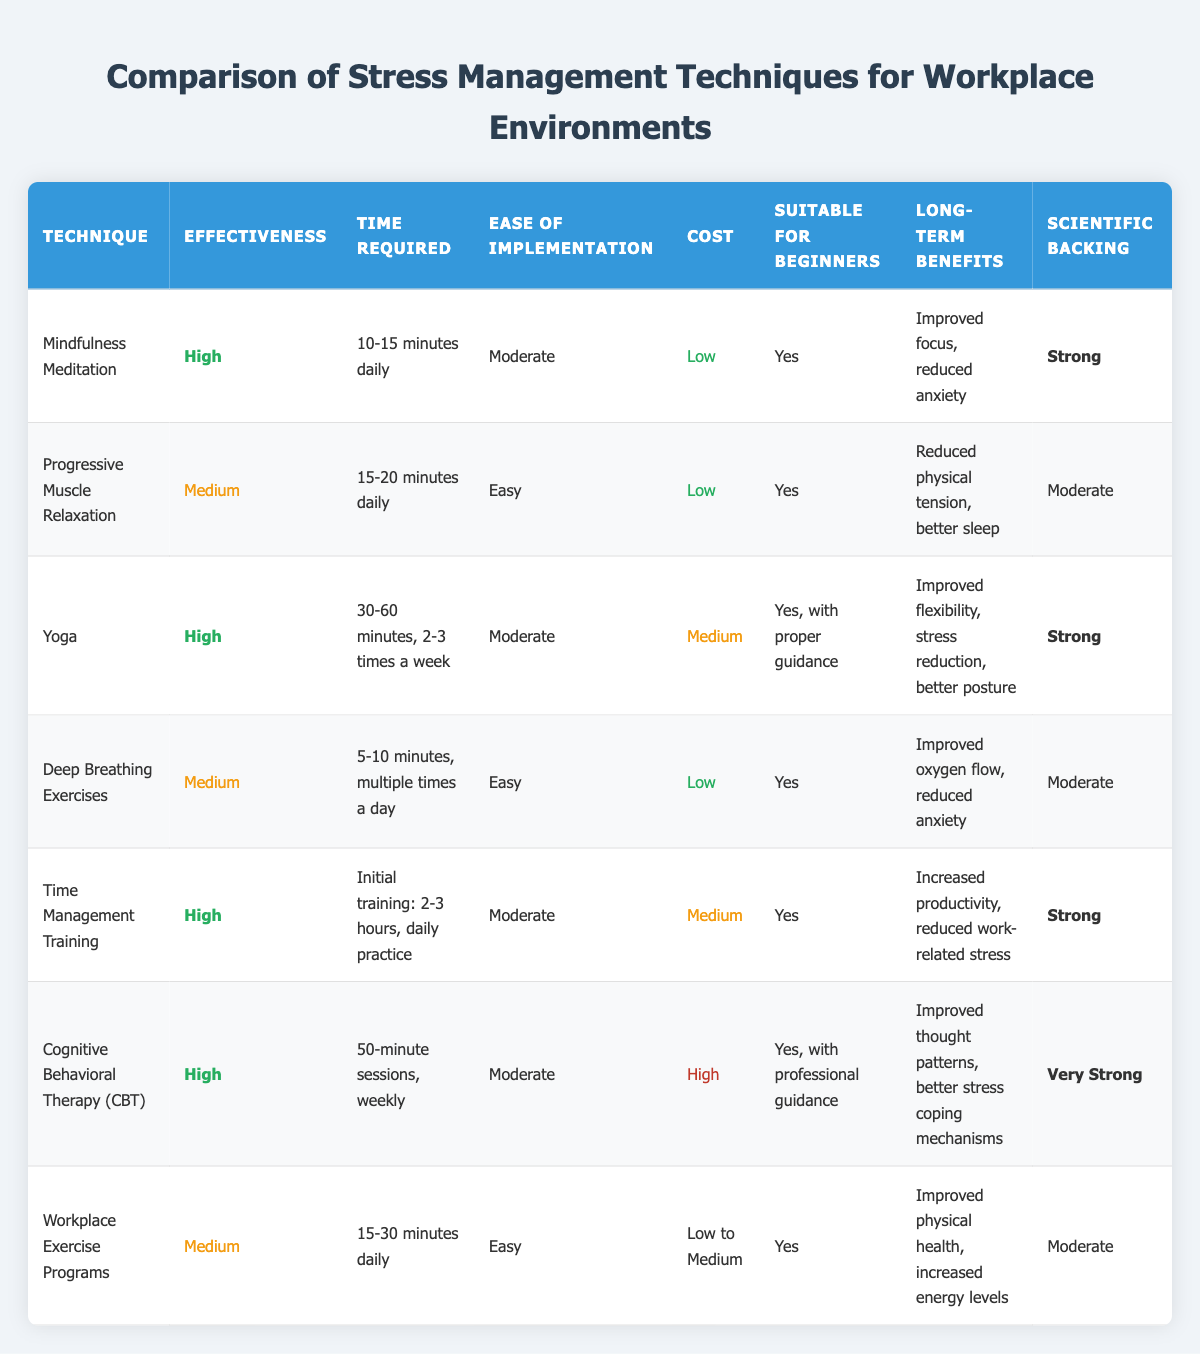What is the effectiveness of Cognitive Behavioral Therapy (CBT)? The effectiveness of Cognitive Behavioral Therapy (CBT) is listed in the table as "High."
Answer: High How much time is required for Mindfulness Meditation? According to the table, the time required for Mindfulness Meditation is "10-15 minutes daily."
Answer: 10-15 minutes daily Is Yoga suitable for beginners according to the table? The table states that Yoga is suitable for beginners "Yes, with proper guidance," indicating that beginners can practice it but may need assistance initially.
Answer: Yes What are the long-term benefits of Time Management Training? The table indicates that the long-term benefits of Time Management Training include "Increased productivity, reduced work-related stress."
Answer: Increased productivity, reduced work-related stress Which technique requires the least amount of time per session? Deep Breathing Exercises require "5-10 minutes, multiple times a day," making it the technique that requires the least amount of time per session compared to others in the table.
Answer: Deep Breathing Exercises Count how many techniques have a low cost. Referring to the table, the techniques with a low cost are Mindfulness Meditation, Progressive Muscle Relaxation, Deep Breathing Exercises, and Workplace Exercise Programs. There are four techniques in total with a low cost category.
Answer: 4 What is the average effectiveness rating of the listed techniques? The effectiveness ratings are categorized as High (4 counts), Medium (3 counts) so calculating the average gives (4*3 + 3*2)/7 = 3.14. In categorical terms, this averages out to between Medium and High, leaning towards High.
Answer: Between Medium and High Which technique has the strongest scientific backing? Cognitive Behavioral Therapy (CBT) is noted in the table to have "Very Strong" scientific backing, which is the highest among the techniques listed.
Answer: Very Strong Are Deep Breathing Exercises classified as easy to implement? The table classifies Deep Breathing Exercises as "Easy," affirming their straightforwardness in practice.
Answer: Yes Calculate the total number of techniques that have medium effectiveness. The table shows three techniques listed as having medium effectiveness: Progressive Muscle Relaxation, Deep Breathing Exercises, and Workplace Exercise Programs. Thus, the total is three techniques.
Answer: 3 